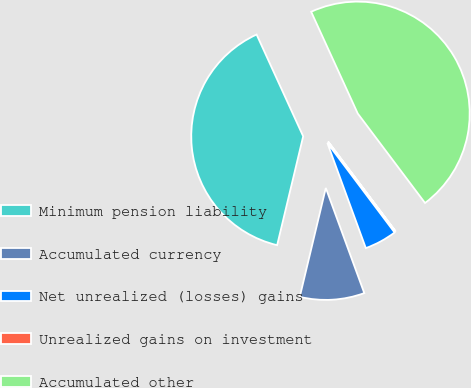Convert chart to OTSL. <chart><loc_0><loc_0><loc_500><loc_500><pie_chart><fcel>Minimum pension liability<fcel>Accumulated currency<fcel>Net unrealized (losses) gains<fcel>Unrealized gains on investment<fcel>Accumulated other<nl><fcel>39.43%<fcel>9.32%<fcel>4.67%<fcel>0.01%<fcel>46.57%<nl></chart> 